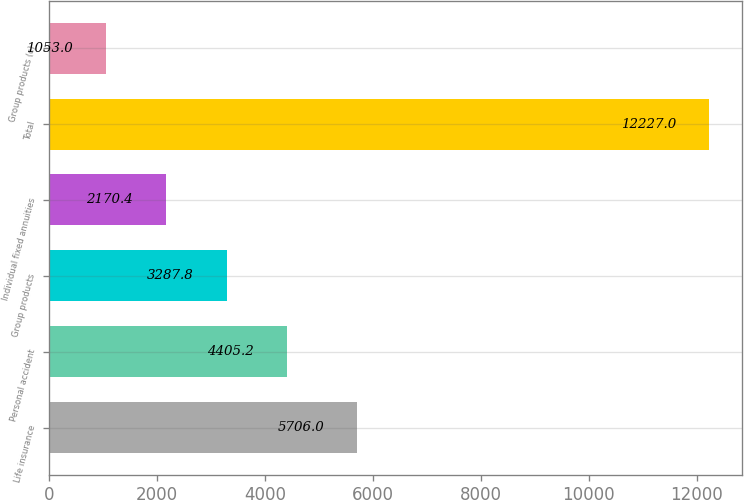<chart> <loc_0><loc_0><loc_500><loc_500><bar_chart><fcel>Life insurance<fcel>Personal accident<fcel>Group products<fcel>Individual fixed annuities<fcel>Total<fcel>Group products (c)<nl><fcel>5706<fcel>4405.2<fcel>3287.8<fcel>2170.4<fcel>12227<fcel>1053<nl></chart> 